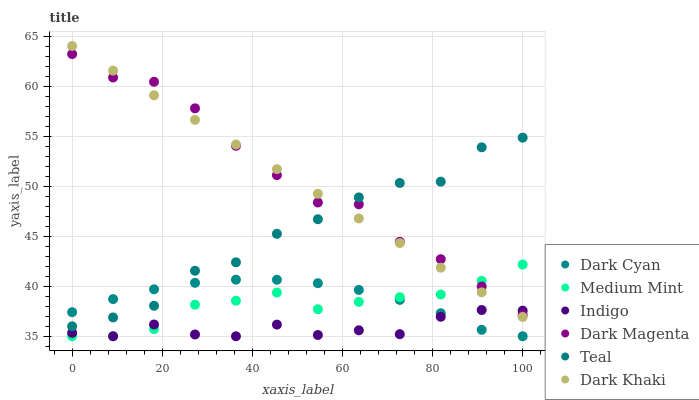Does Indigo have the minimum area under the curve?
Answer yes or no. Yes. Does Dark Magenta have the maximum area under the curve?
Answer yes or no. Yes. Does Dark Magenta have the minimum area under the curve?
Answer yes or no. No. Does Indigo have the maximum area under the curve?
Answer yes or no. No. Is Dark Khaki the smoothest?
Answer yes or no. Yes. Is Teal the roughest?
Answer yes or no. Yes. Is Indigo the smoothest?
Answer yes or no. No. Is Indigo the roughest?
Answer yes or no. No. Does Medium Mint have the lowest value?
Answer yes or no. Yes. Does Dark Magenta have the lowest value?
Answer yes or no. No. Does Dark Khaki have the highest value?
Answer yes or no. Yes. Does Dark Magenta have the highest value?
Answer yes or no. No. Is Indigo less than Teal?
Answer yes or no. Yes. Is Teal greater than Indigo?
Answer yes or no. Yes. Does Dark Khaki intersect Dark Magenta?
Answer yes or no. Yes. Is Dark Khaki less than Dark Magenta?
Answer yes or no. No. Is Dark Khaki greater than Dark Magenta?
Answer yes or no. No. Does Indigo intersect Teal?
Answer yes or no. No. 